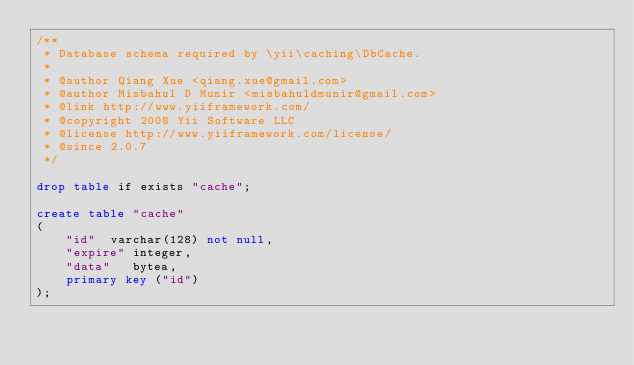Convert code to text. <code><loc_0><loc_0><loc_500><loc_500><_SQL_>/**
 * Database schema required by \yii\caching\DbCache.
 *
 * @author Qiang Xue <qiang.xue@gmail.com>
 * @author Misbahul D Munir <misbahuldmunir@gmail.com>
 * @link http://www.yiiframework.com/
 * @copyright 2008 Yii Software LLC
 * @license http://www.yiiframework.com/license/
 * @since 2.0.7
 */

drop table if exists "cache";

create table "cache"
(
    "id"  varchar(128) not null,
    "expire" integer,
    "data"   bytea,
    primary key ("id")
);
</code> 